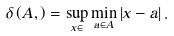<formula> <loc_0><loc_0><loc_500><loc_500>\delta \left ( A , \overline { \Omega } \right ) = \sup _ { x \in \Omega } \min _ { a \in A } \left | x - a \right | .</formula> 